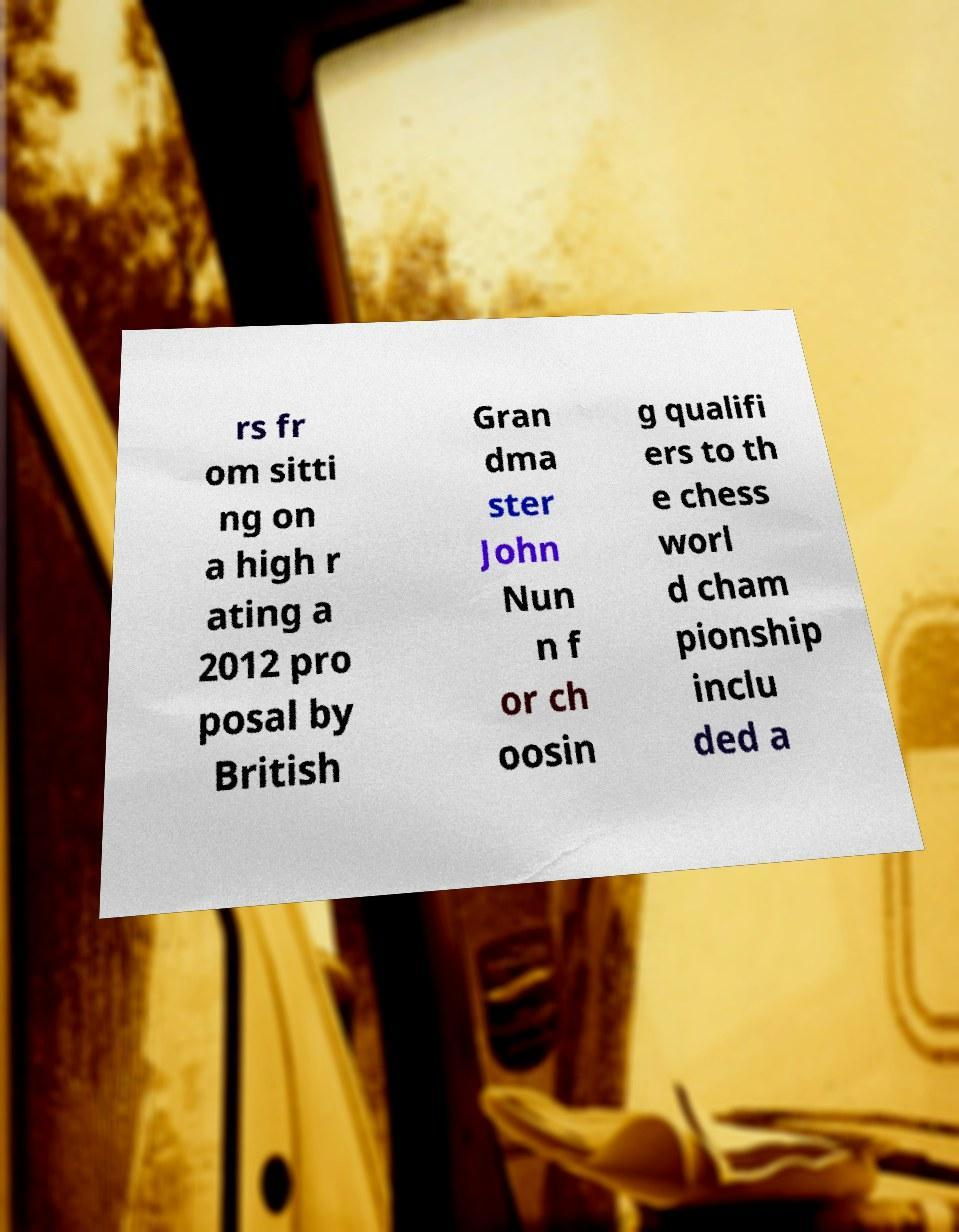Can you accurately transcribe the text from the provided image for me? rs fr om sitti ng on a high r ating a 2012 pro posal by British Gran dma ster John Nun n f or ch oosin g qualifi ers to th e chess worl d cham pionship inclu ded a 